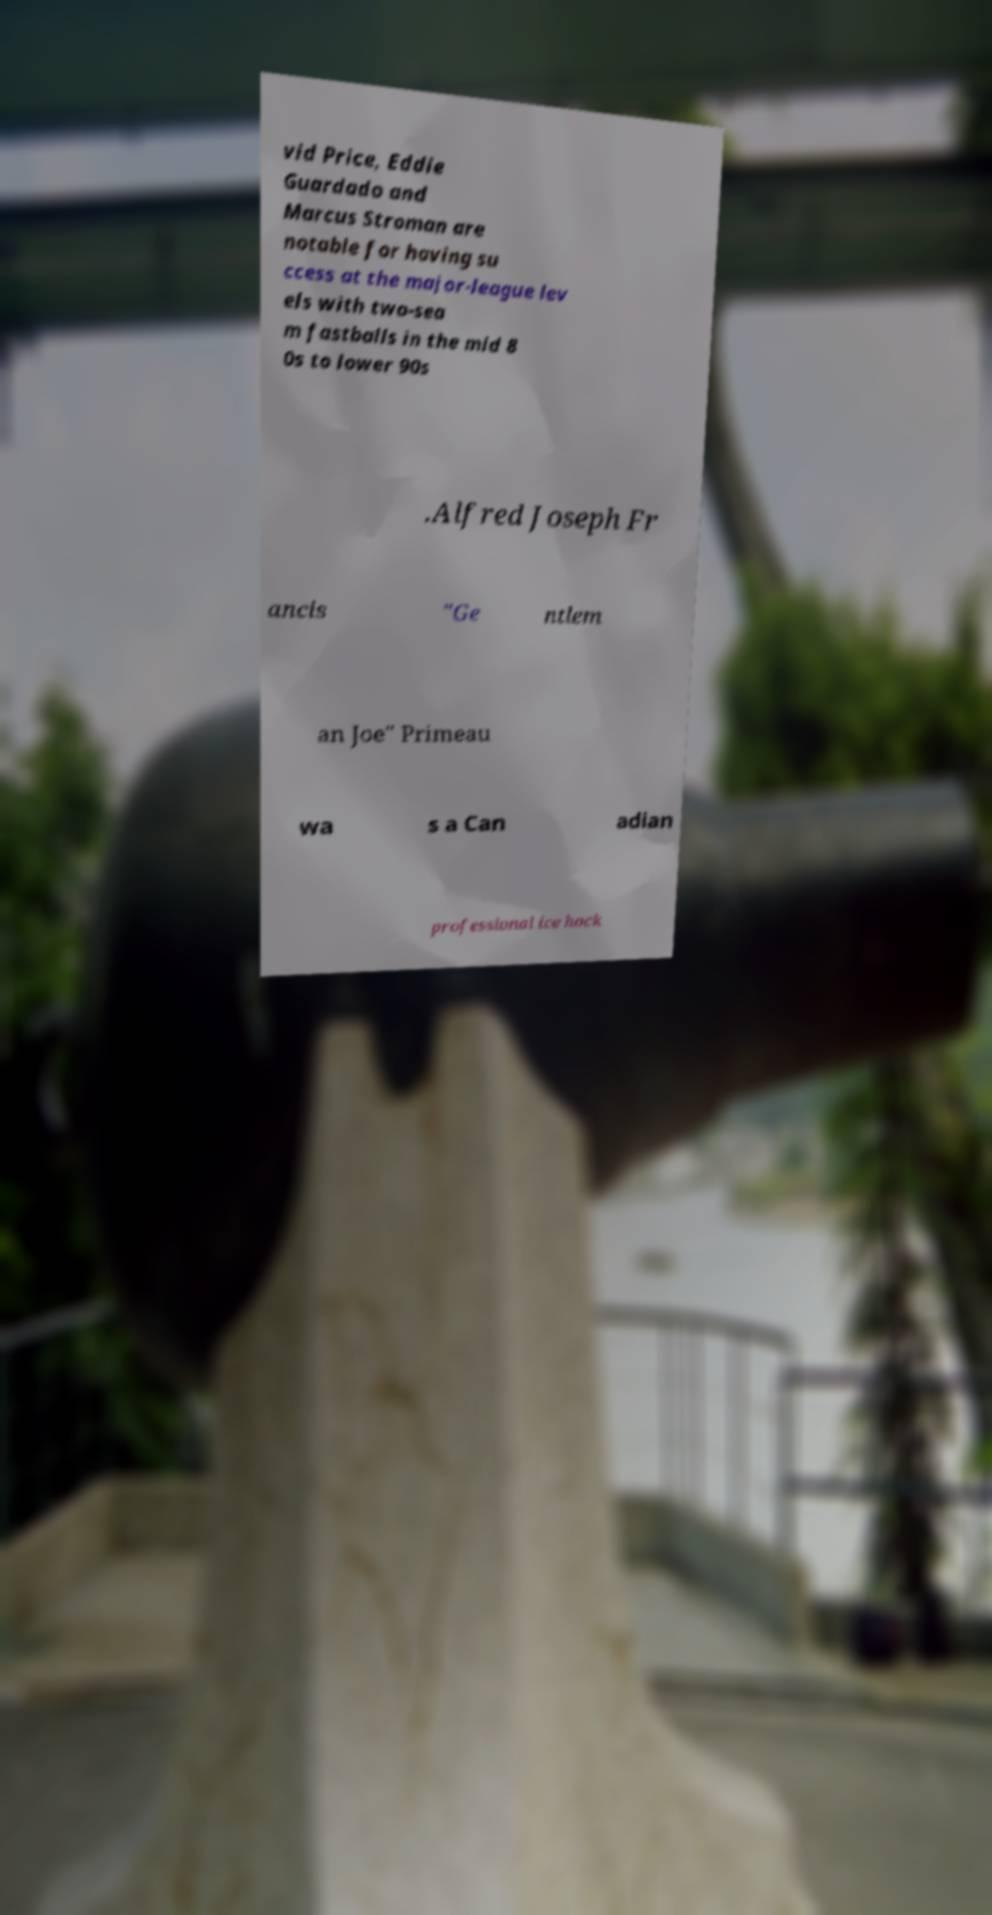Please read and relay the text visible in this image. What does it say? vid Price, Eddie Guardado and Marcus Stroman are notable for having su ccess at the major-league lev els with two-sea m fastballs in the mid 8 0s to lower 90s .Alfred Joseph Fr ancis "Ge ntlem an Joe" Primeau wa s a Can adian professional ice hock 